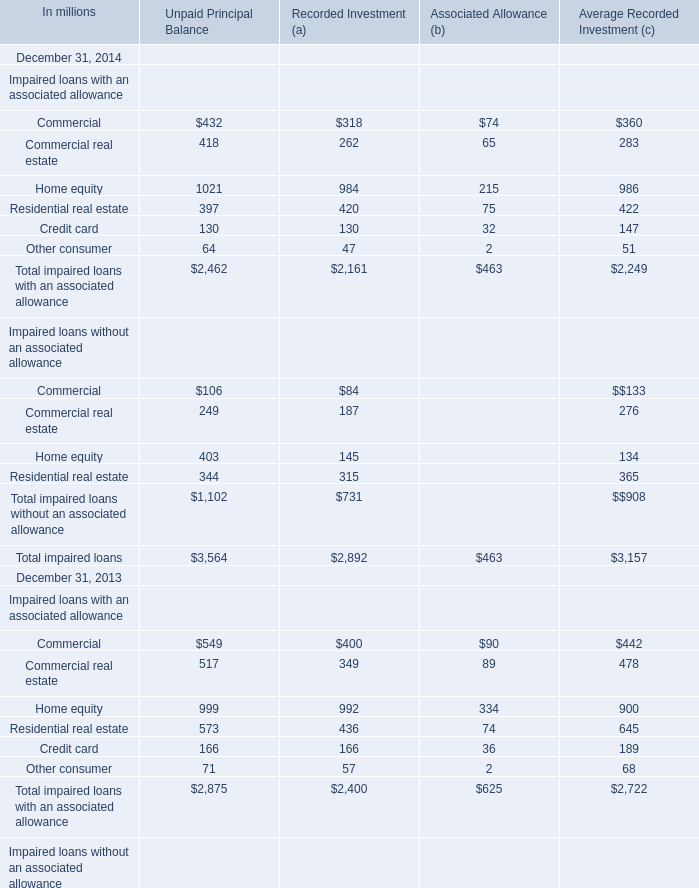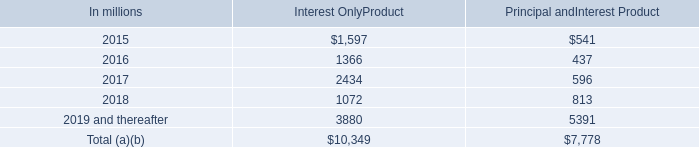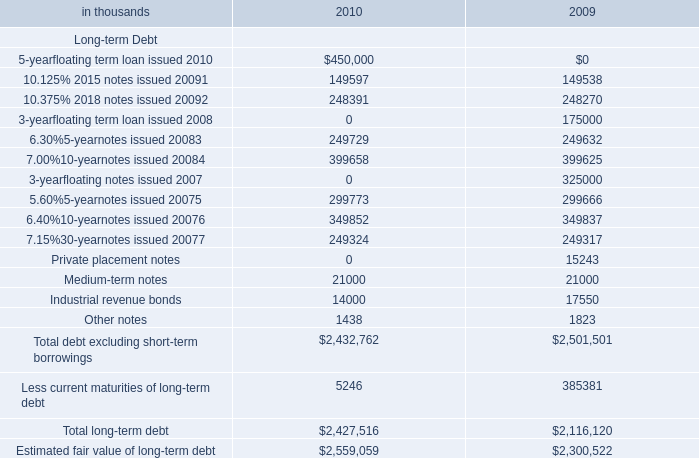Which year is Total impaired loans without an associated allowance for Recorded Investment (a) on December 31 the least? 
Answer: 2014. 